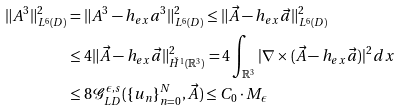Convert formula to latex. <formula><loc_0><loc_0><loc_500><loc_500>\| A ^ { 3 } \| _ { L ^ { 6 } ( D ) } ^ { 2 } & = \| A ^ { 3 } - h _ { e x } a ^ { 3 } \| _ { L ^ { 6 } ( D ) } ^ { 2 } \leq \| \vec { A } - h _ { e x } \vec { a } \| _ { L ^ { 6 } ( D ) } ^ { 2 } \\ & \leq 4 \| \vec { A } - h _ { e x } \vec { a } \| _ { \check { H } ^ { 1 } ( \mathbb { R } ^ { 3 } ) } ^ { 2 } = 4 \int _ { \mathbb { R } ^ { 3 } } | \nabla \times ( \vec { A } - h _ { e x } \vec { a } ) | ^ { 2 } d x \\ & \leq 8 \mathcal { G } _ { L D } ^ { \epsilon , s } ( \{ u _ { n } \} _ { n = 0 } ^ { N } , \vec { A } ) \leq C _ { 0 } \cdot M _ { \epsilon }</formula> 